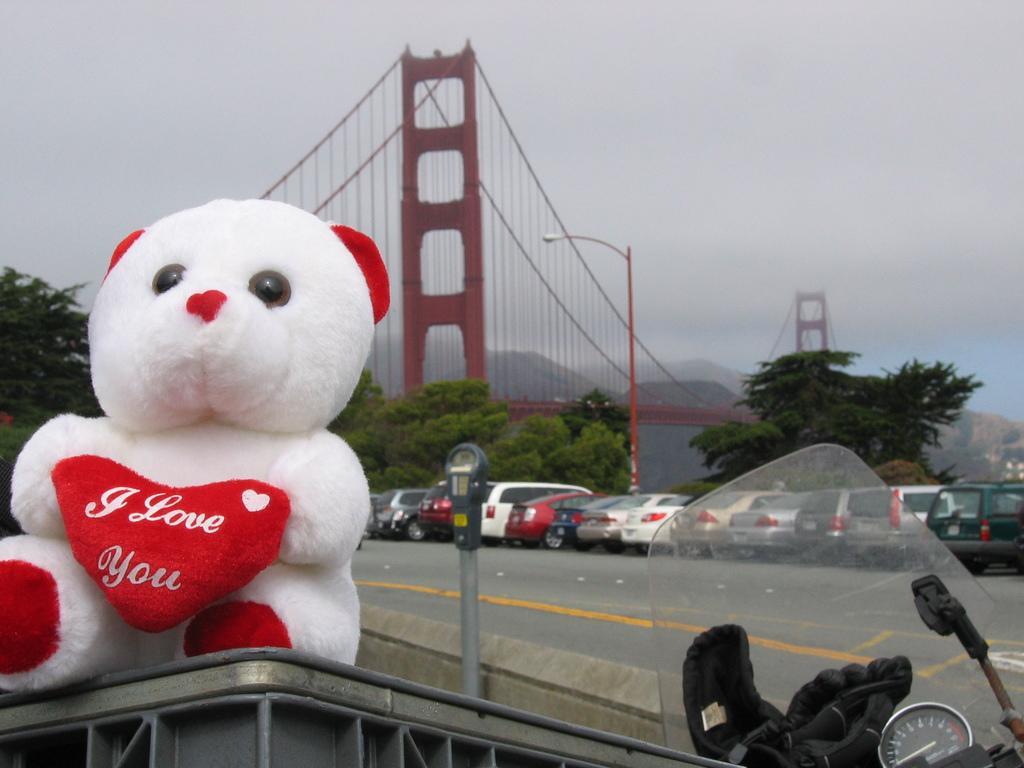In one or two sentences, can you explain what this image depicts? This picture is clicked outside. On the left we can see a white color soft toy placed on a metal object. On the right corner we can see the glove and some part of the bike. In the background we can see the sky, bridge, ropes, trees, group of cars, hills and some other objects and we can see the lamp post. 